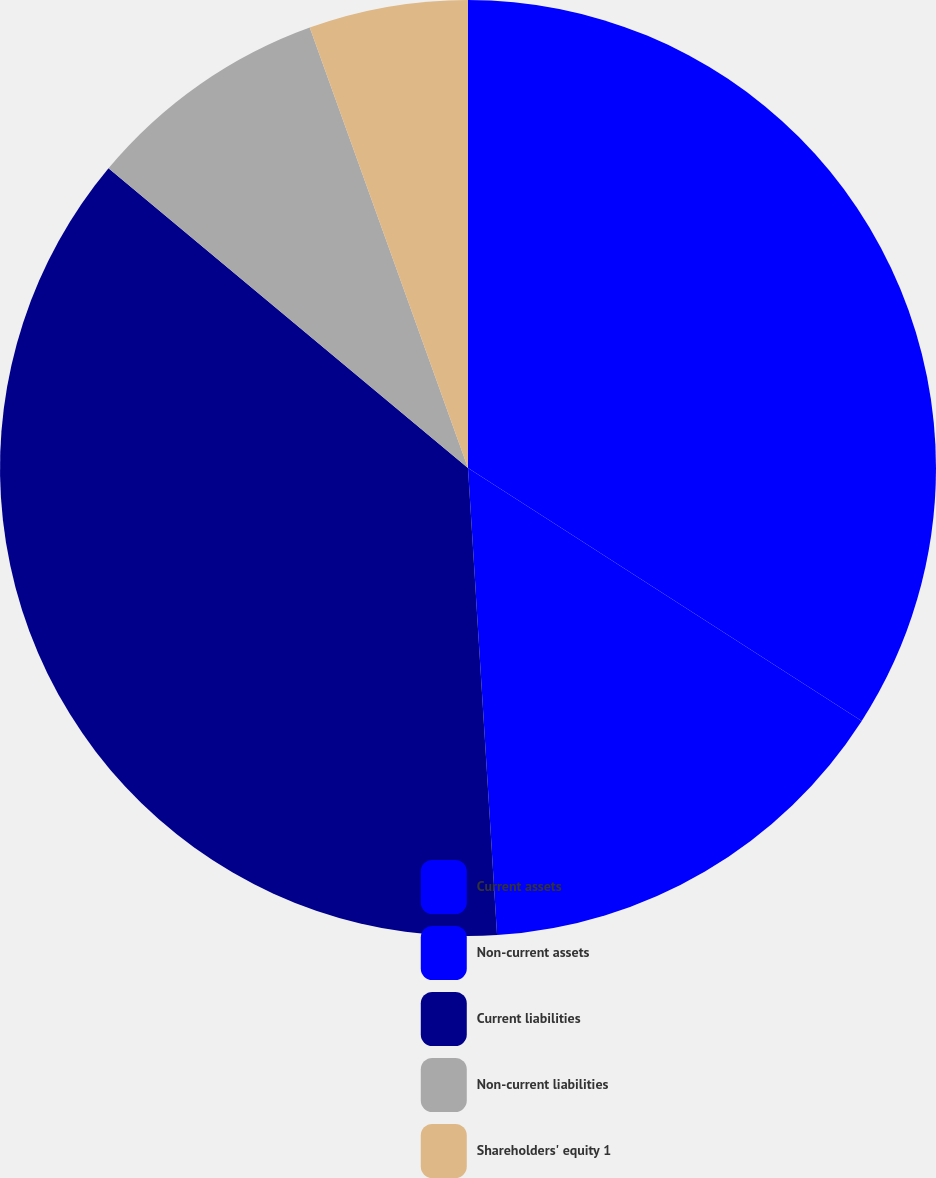<chart> <loc_0><loc_0><loc_500><loc_500><pie_chart><fcel>Current assets<fcel>Non-current assets<fcel>Current liabilities<fcel>Non-current liabilities<fcel>Shareholders' equity 1<nl><fcel>34.09%<fcel>14.92%<fcel>37.05%<fcel>8.45%<fcel>5.49%<nl></chart> 